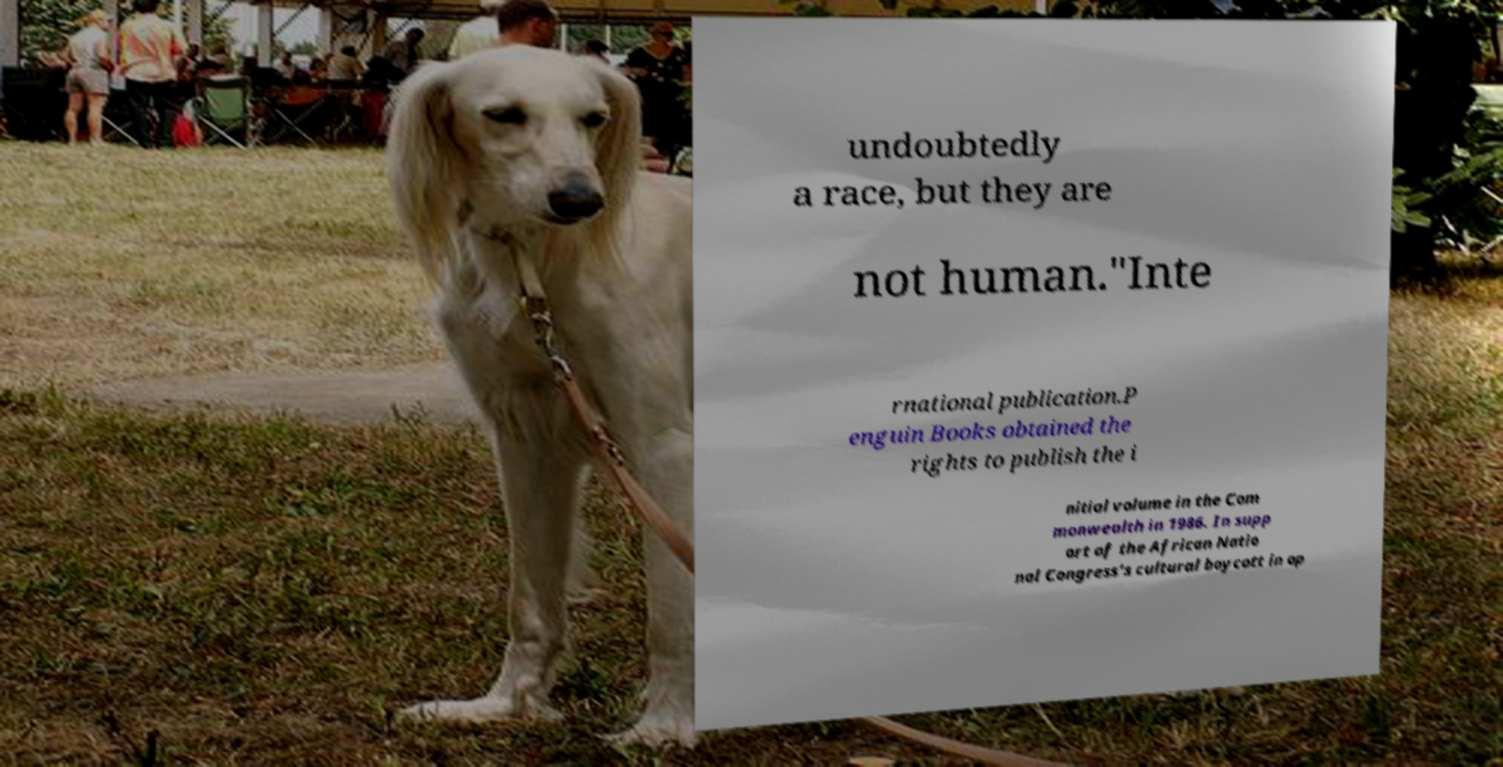Could you extract and type out the text from this image? undoubtedly a race, but they are not human."Inte rnational publication.P enguin Books obtained the rights to publish the i nitial volume in the Com monwealth in 1986. In supp ort of the African Natio nal Congress's cultural boycott in op 